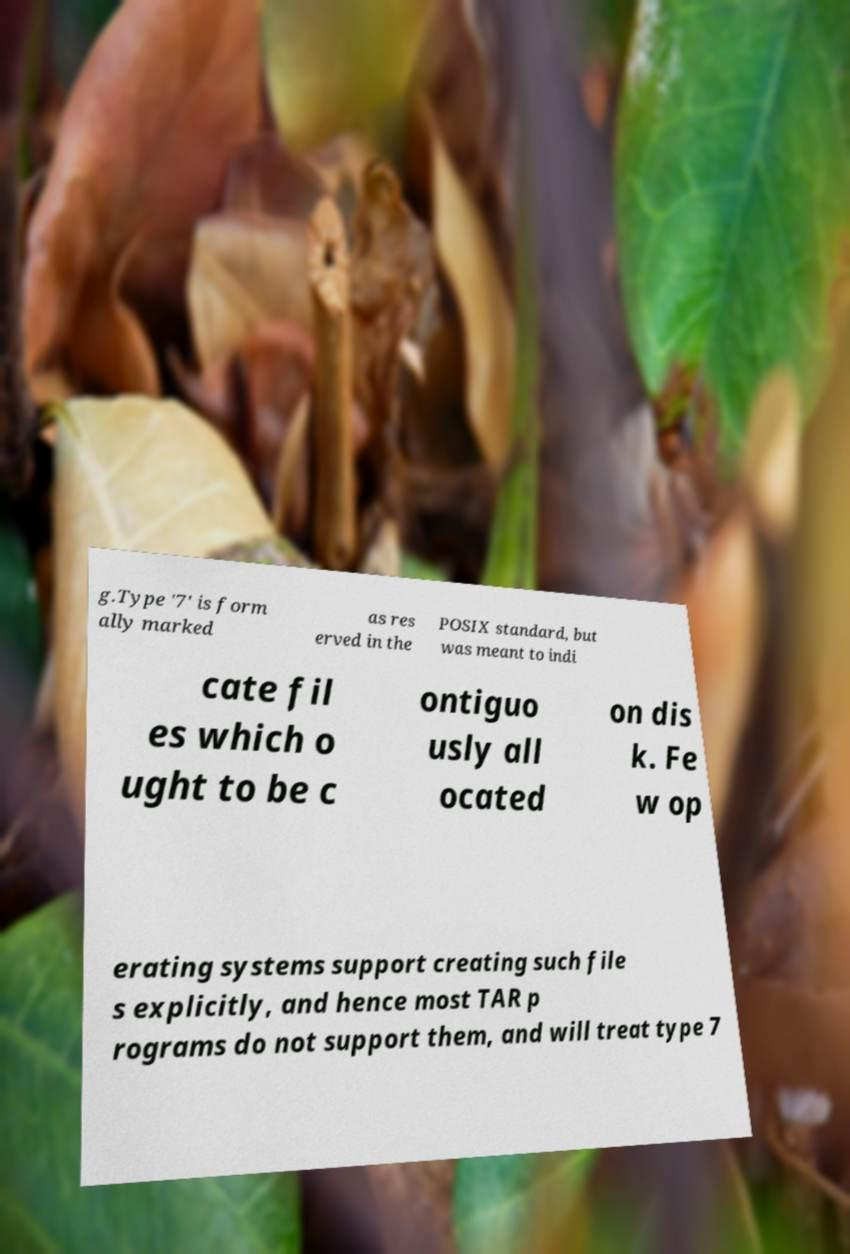Could you extract and type out the text from this image? g.Type '7' is form ally marked as res erved in the POSIX standard, but was meant to indi cate fil es which o ught to be c ontiguo usly all ocated on dis k. Fe w op erating systems support creating such file s explicitly, and hence most TAR p rograms do not support them, and will treat type 7 